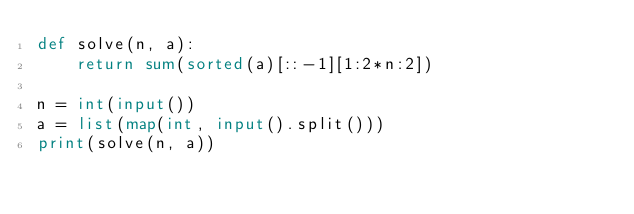<code> <loc_0><loc_0><loc_500><loc_500><_Python_>def solve(n, a):
    return sum(sorted(a)[::-1][1:2*n:2])

n = int(input())
a = list(map(int, input().split()))
print(solve(n, a))
</code> 